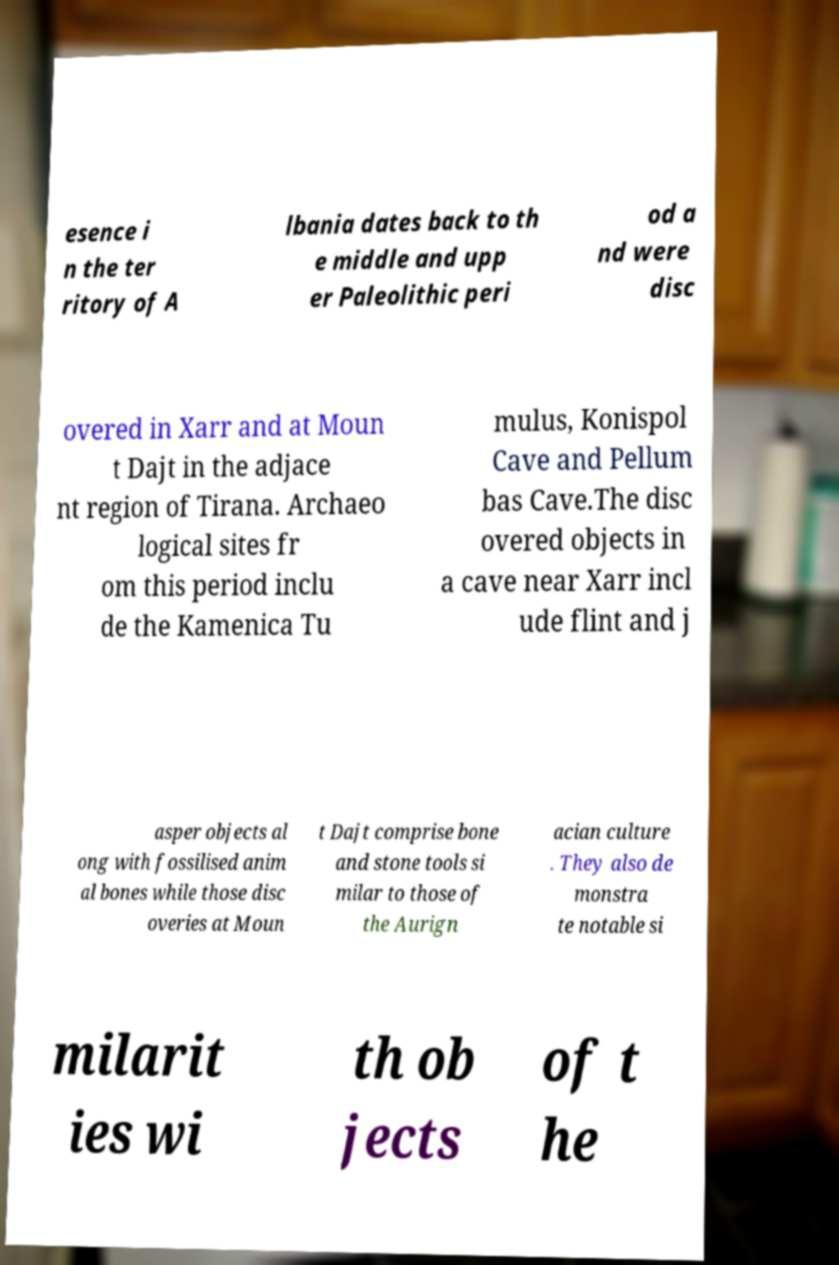Please identify and transcribe the text found in this image. esence i n the ter ritory of A lbania dates back to th e middle and upp er Paleolithic peri od a nd were disc overed in Xarr and at Moun t Dajt in the adjace nt region of Tirana. Archaeo logical sites fr om this period inclu de the Kamenica Tu mulus, Konispol Cave and Pellum bas Cave.The disc overed objects in a cave near Xarr incl ude flint and j asper objects al ong with fossilised anim al bones while those disc overies at Moun t Dajt comprise bone and stone tools si milar to those of the Aurign acian culture . They also de monstra te notable si milarit ies wi th ob jects of t he 